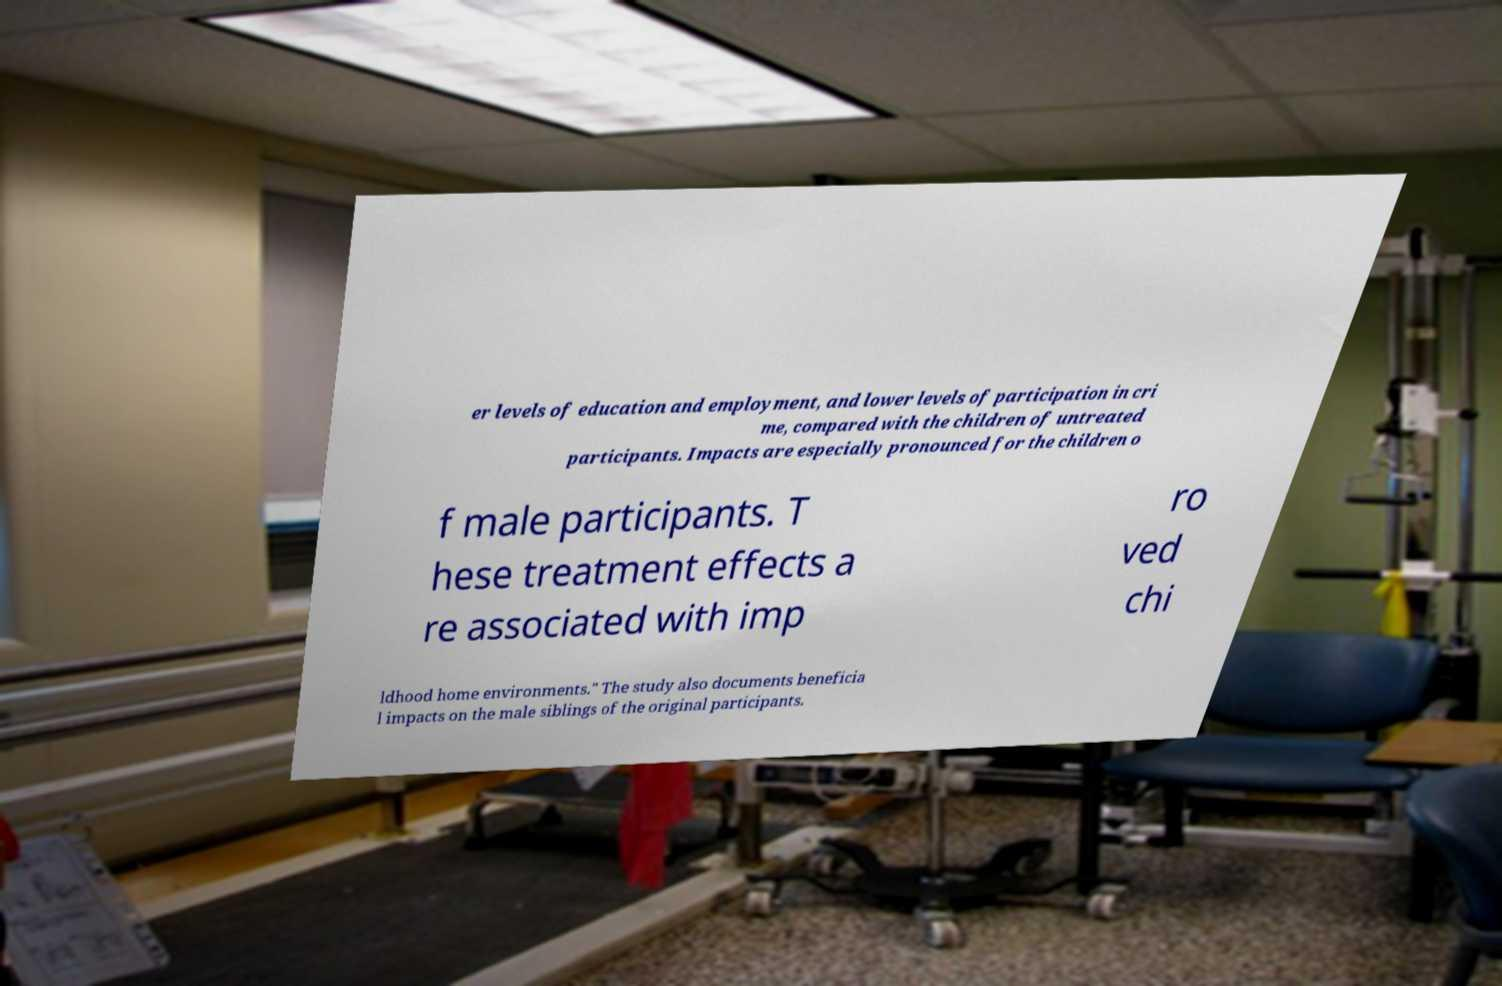Could you assist in decoding the text presented in this image and type it out clearly? er levels of education and employment, and lower levels of participation in cri me, compared with the children of untreated participants. Impacts are especially pronounced for the children o f male participants. T hese treatment effects a re associated with imp ro ved chi ldhood home environments." The study also documents beneficia l impacts on the male siblings of the original participants. 